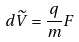Convert formula to latex. <formula><loc_0><loc_0><loc_500><loc_500>d \widetilde { V } = \frac { q } { m } F</formula> 